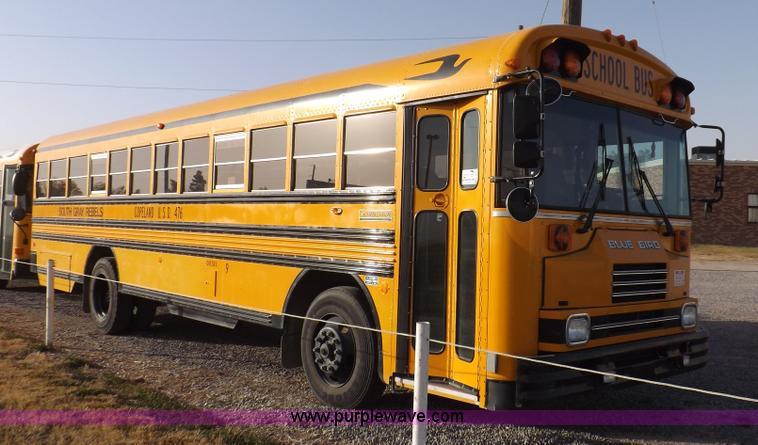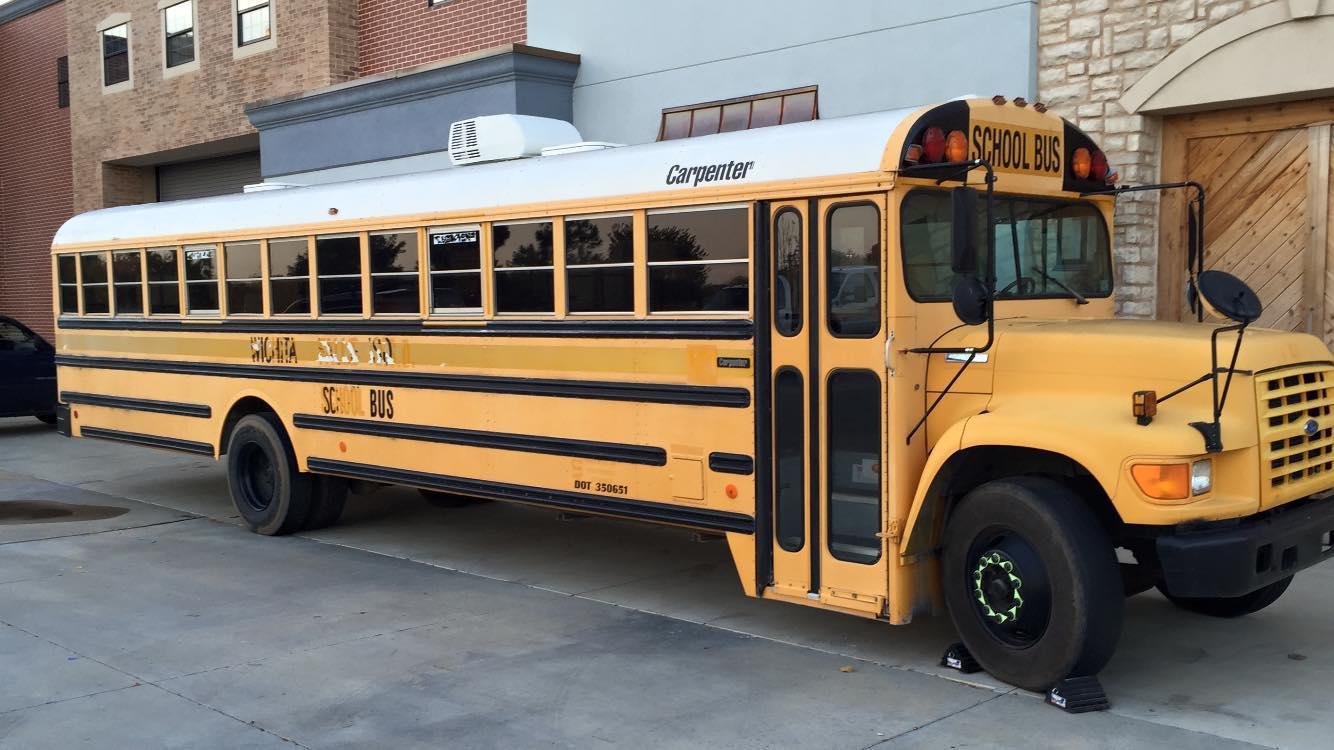The first image is the image on the left, the second image is the image on the right. Given the left and right images, does the statement "Exactly one bus stop sign is visible." hold true? Answer yes or no. No. The first image is the image on the left, the second image is the image on the right. Analyze the images presented: Is the assertion "One image shows a bus with a flat front, and the other image shows a bus with a non-flat front." valid? Answer yes or no. Yes. 